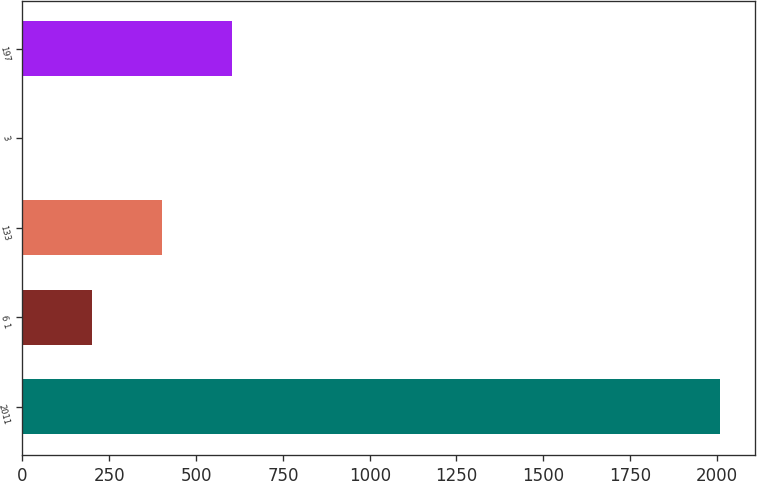Convert chart. <chart><loc_0><loc_0><loc_500><loc_500><bar_chart><fcel>2011<fcel>6 1<fcel>133<fcel>3<fcel>197<nl><fcel>2010<fcel>201.44<fcel>402.39<fcel>0.49<fcel>603.34<nl></chart> 